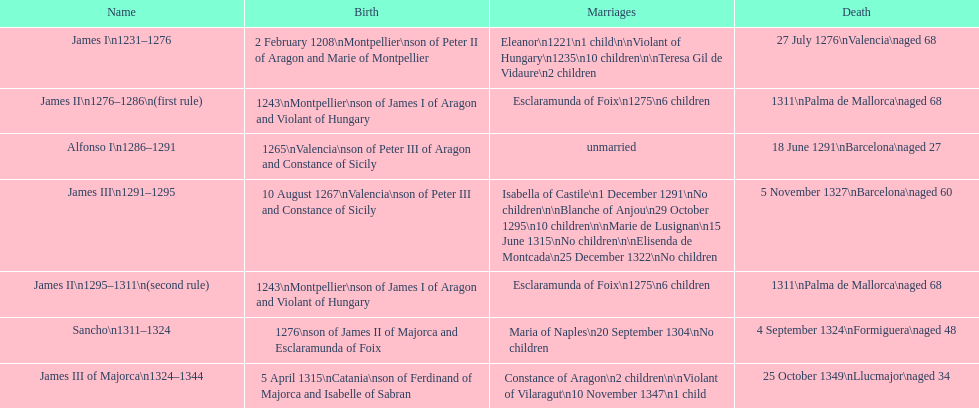Which monarch is listed first? James I 1231-1276. 